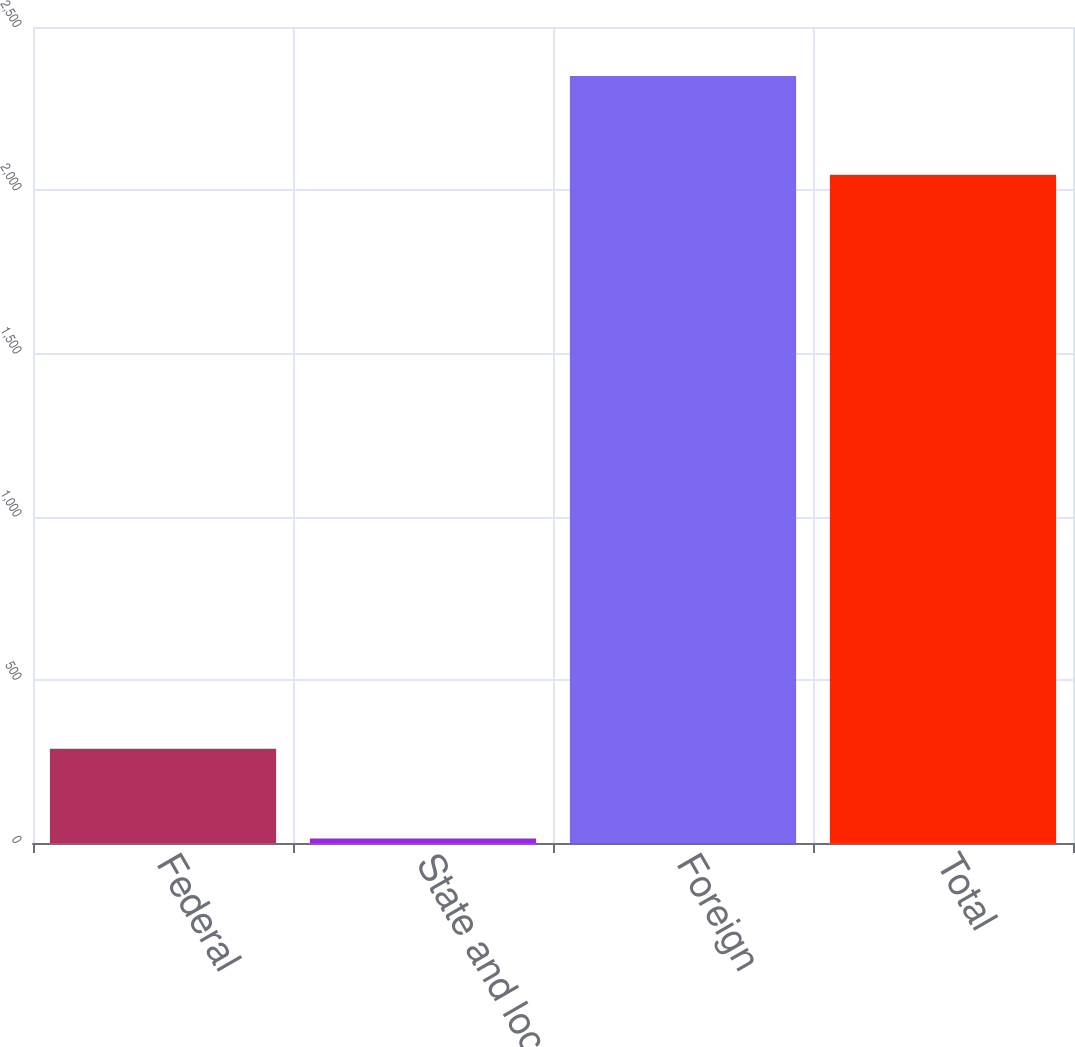<chart> <loc_0><loc_0><loc_500><loc_500><bar_chart><fcel>Federal<fcel>State and local<fcel>Foreign<fcel>Total<nl><fcel>289<fcel>14<fcel>2350<fcel>2047<nl></chart> 